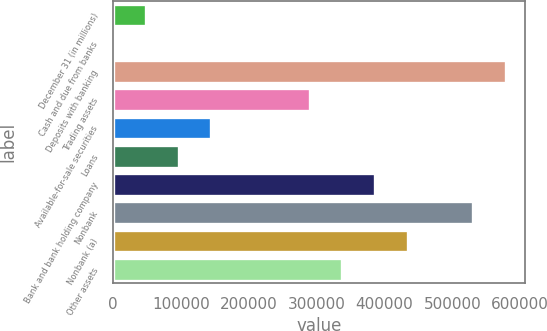<chart> <loc_0><loc_0><loc_500><loc_500><bar_chart><fcel>December 31 (in millions)<fcel>Cash and due from banks<fcel>Deposits with banking<fcel>Trading assets<fcel>Available-for-sale securities<fcel>Loans<fcel>Bank and bank holding company<fcel>Nonbank<fcel>Nonbank (a)<fcel>Other assets<nl><fcel>48412.1<fcel>211<fcel>578624<fcel>289418<fcel>144814<fcel>96613.2<fcel>385820<fcel>530423<fcel>434021<fcel>337619<nl></chart> 